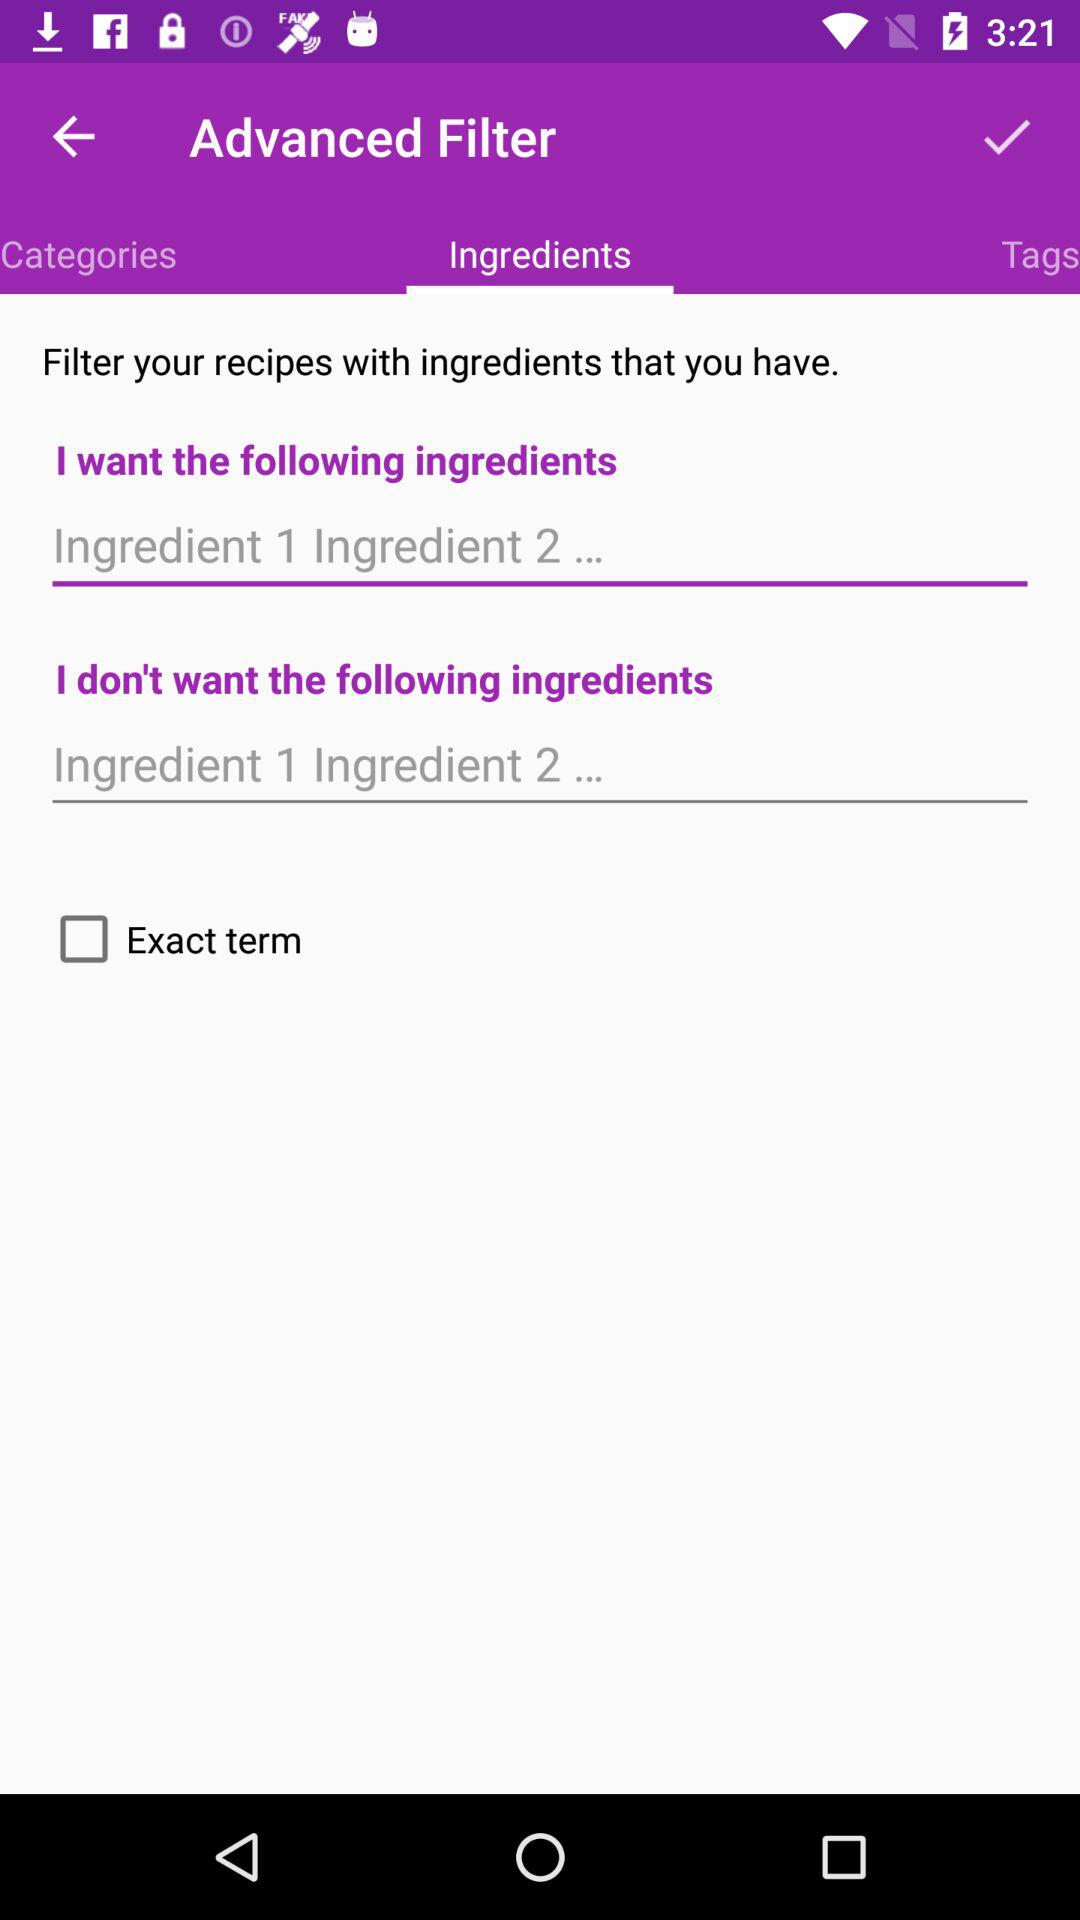What tab am I using? The tab is "Ingredients". 